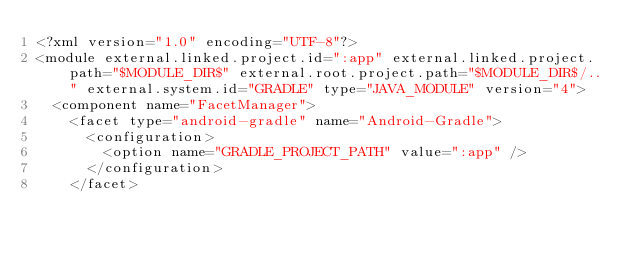Convert code to text. <code><loc_0><loc_0><loc_500><loc_500><_XML_><?xml version="1.0" encoding="UTF-8"?>
<module external.linked.project.id=":app" external.linked.project.path="$MODULE_DIR$" external.root.project.path="$MODULE_DIR$/.." external.system.id="GRADLE" type="JAVA_MODULE" version="4">
  <component name="FacetManager">
    <facet type="android-gradle" name="Android-Gradle">
      <configuration>
        <option name="GRADLE_PROJECT_PATH" value=":app" />
      </configuration>
    </facet></code> 